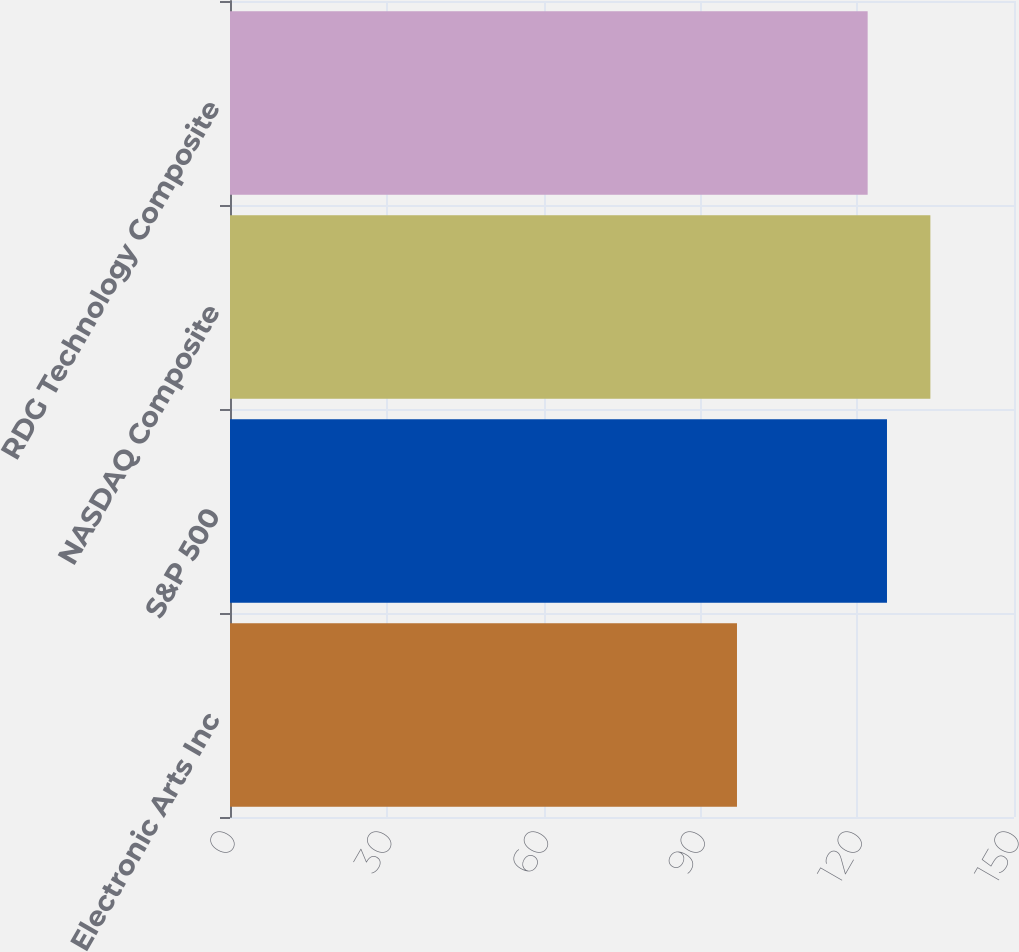<chart> <loc_0><loc_0><loc_500><loc_500><bar_chart><fcel>Electronic Arts Inc<fcel>S&P 500<fcel>NASDAQ Composite<fcel>RDG Technology Composite<nl><fcel>97<fcel>125.7<fcel>134<fcel>122<nl></chart> 